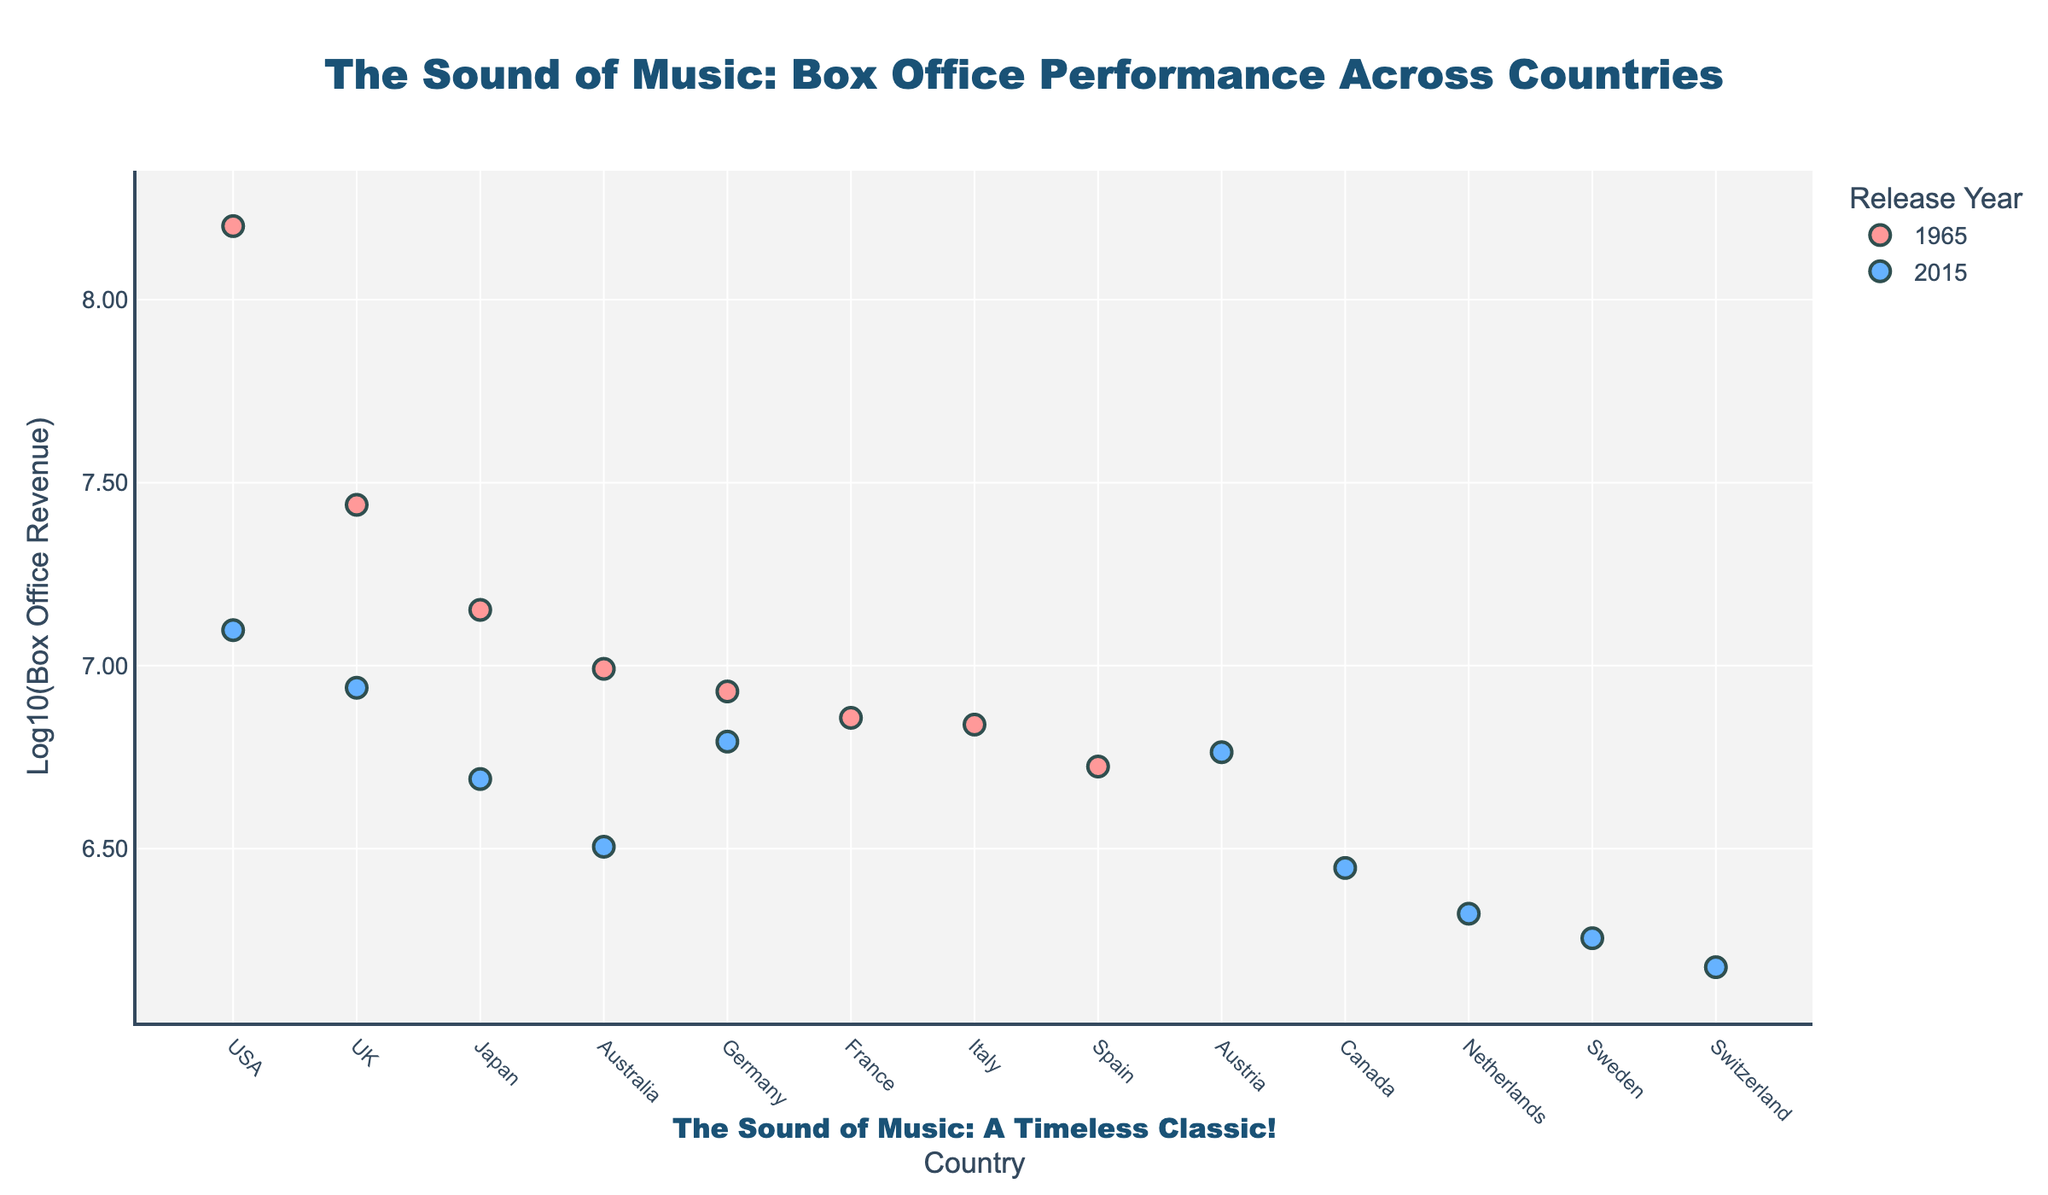What's the title of the plot? The title is found at the top center of the plot and it reads "The Sound of Music: Box Office Performance Across Countries".
Answer: The Sound of Music: Box Office Performance Across Countries What axis represents the countries? The x-axis represents the countries, indicated by the label "Country".
Answer: The x-axis What color represents the 1965 data points? The 1965 data points are represented by pink-colored markers.
Answer: Pink Which country's "The Sound of Music" adaptation had the highest box office in 1965? On the x-axis, locate "USA" and notice it has the highest y-value for 1965 data points.
Answer: USA What is the y-axis title in the plot? The title for the y-axis is "Log10(Box Office Revenue)".
Answer: Log10(Box Office Revenue) How many countries are included in the 2015 data? Count the distinct markers for the year 2015 on the x-axis.
Answer: 8 What's the difference in log box office revenue between USA 1965 and USA 2015? The log box office revenue for USA 1965 is approximately 8.2, and for USA 2015 is approximately 7.1. Difference: 8.2 - 7.1 ≈ 1.1.
Answer: 1.1 Which year had a higher overall box office revenue for the UK? Locate the markers for UK; the one for 1965 is higher on the y-axis than 2015, indicating a higher box office revenue.
Answer: 1965 What is the average log box office revenue for the 2015 data points? Convert the 2015 box office revenues to logarithmic values, sum them up and divide by the number of data points (8): (7.1 + 6.9 + 6.8 + 6.8 + 6.7 + 6.5 + 6.4 + 6.3)/8 ≈ 6.68.
Answer: ≈ 6.68 Which country's adaptation in 2015 had the lowest box office revenue? The country with the lowest marker on the y-axis for the 2015 data points is Switzerland.
Answer: Switzerland 